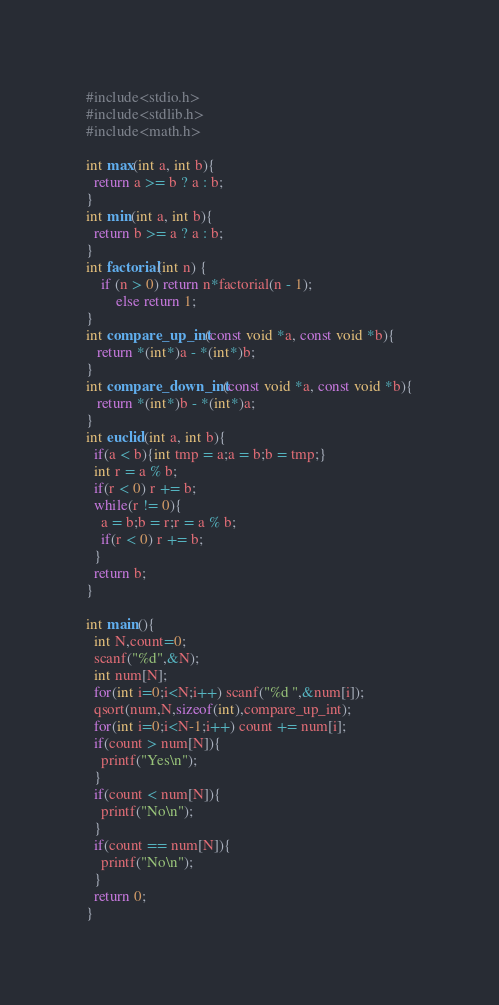<code> <loc_0><loc_0><loc_500><loc_500><_C_>#include<stdio.h>
#include<stdlib.h>
#include<math.h>

int max(int a, int b){
  return a >= b ? a : b;
}
int min(int a, int b){
  return b >= a ? a : b;
}
int factorial(int n) {
    if (n > 0) return n*factorial(n - 1);
		else return 1;
}
int compare_up_int(const void *a, const void *b){
   return *(int*)a - *(int*)b;
}
int compare_down_int(const void *a, const void *b){
   return *(int*)b - *(int*)a;
}
int euclid(int a, int b){
  if(a < b){int tmp = a;a = b;b = tmp;}
  int r = a % b;
  if(r < 0) r += b;
  while(r != 0){
    a = b;b = r;r = a % b;
    if(r < 0) r += b;
  }
  return b;
}

int main(){
  int N,count=0;
  scanf("%d",&N);
  int num[N];
  for(int i=0;i<N;i++) scanf("%d ",&num[i]);
  qsort(num,N,sizeof(int),compare_up_int);
  for(int i=0;i<N-1;i++) count += num[i];
  if(count > num[N]){
    printf("Yes\n");
  }
  if(count < num[N]){
    printf("No\n");
  }
  if(count == num[N]){
    printf("No\n");
  }
  return 0;
}
</code> 